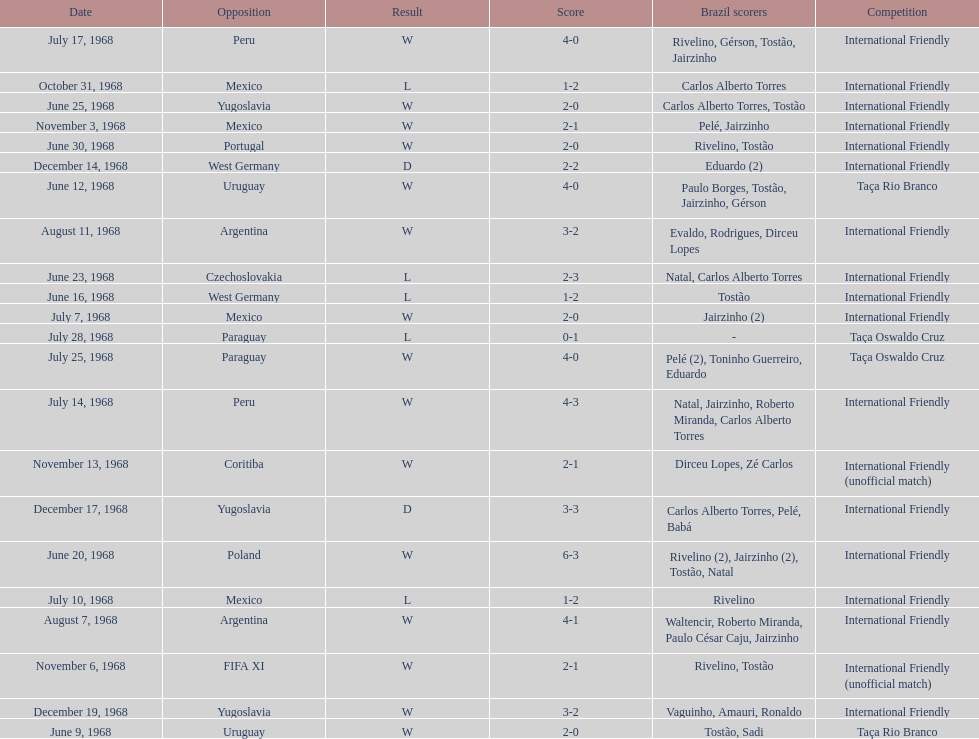How many contests are triumphs? 15. 